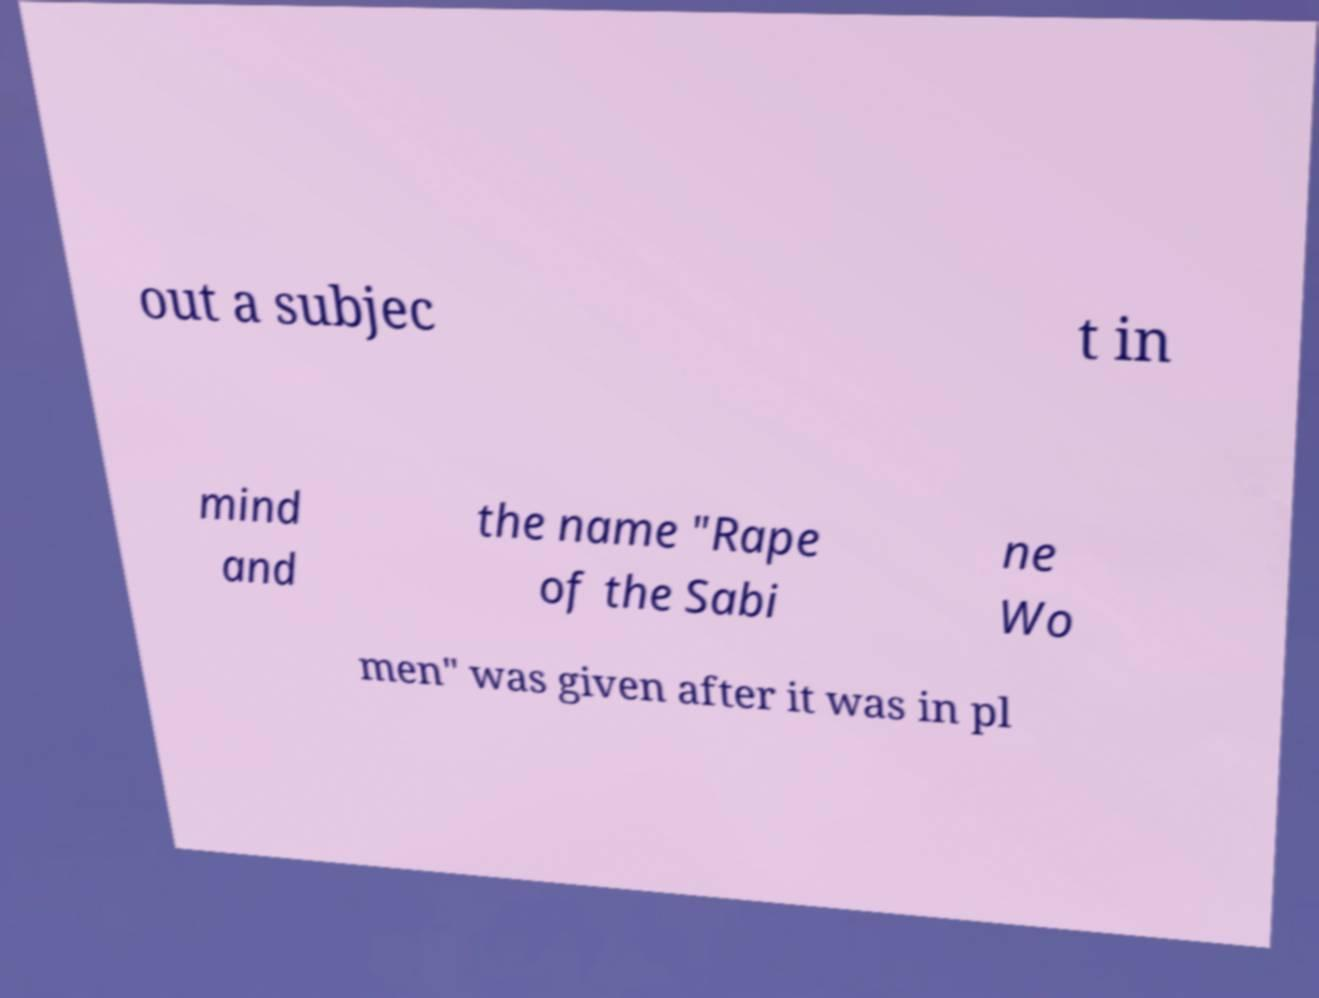Please read and relay the text visible in this image. What does it say? out a subjec t in mind and the name "Rape of the Sabi ne Wo men" was given after it was in pl 